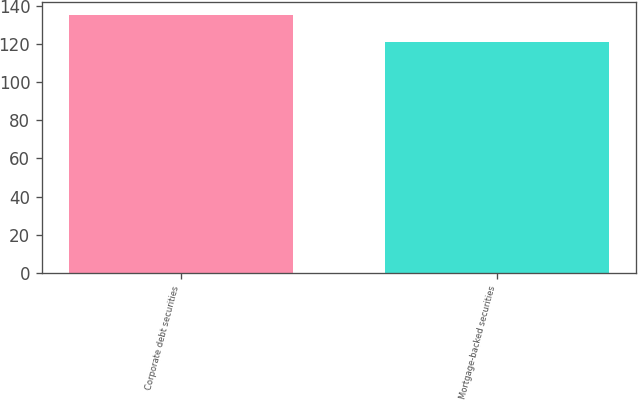Convert chart. <chart><loc_0><loc_0><loc_500><loc_500><bar_chart><fcel>Corporate debt securities<fcel>Mortgage-backed securities<nl><fcel>135<fcel>121<nl></chart> 